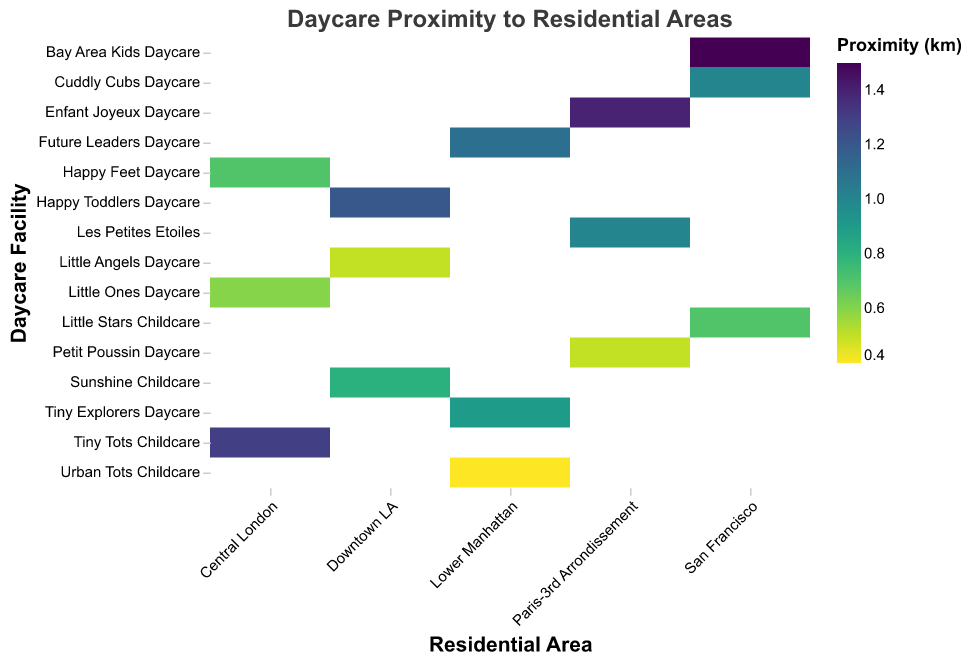what is the title of the heatmap? The heatmap's title is positioned at the top of the figure and describes the main subject of the data visualization. From the provided code, the title is given as "Daycare Proximity to Residential Areas".
Answer: Daycare Proximity to Residential Areas Which daycare facility is closest to a residential area in Lower Manhattan? To find the closest daycare facility, look for the daycare with the lowest proximity value in Lower Manhattan. From the data, "Urban Tots Childcare" has the smallest proximity value of 0.4 km in Lower Manhattan.
Answer: Urban Tots Childcare What is the smallest proximity value in Downtown LA? In Downtown LA, the proximity values are 0.5 (Little Angels Daycare), 1.2 (Happy Toddlers Daycare), and 0.8 (Sunshine Childcare). The smallest value is 0.5 km for Little Angels Daycare.
Answer: 0.5 km Which city has the daycare with the greatest average proximity to residential areas? Calculate the averages for each city: 
- Downtown LA: (0.5 + 1.2 + 0.8) / 3 = 0.83 km 
- San Francisco: (1.0 + 0.7 + 1.5) / 3 = 1.07 km 
- Lower Manhattan: (0.9 + 0.4 + 1.1) / 3 = 0.8 km 
- Central London: (0.6 + 1.3 + 0.7) / 3 = 0.87 km 
- Paris-3rd Arrondissement: (0.5 + 1.0 + 1.4) / 3 = 0.97 km 
San Francisco has the highest average proximity value of 1.07 km.
Answer: San Francisco Which residential area has the most daycare facilities within 1 km? Count the number of daycare facilities for each residential area with proximity values less than or equal to 1 km:
- Downtown LA: 2 (Little Angels Daycare, Sunshine Childcare)
- San Francisco: 2 (Cuddly Cubs Daycare, Little Stars Childcare)
- Lower Manhattan: 2 (Tiny Explorers Daycare, Urban Tots Childcare)
- Central London: 2 (Little Ones Daycare, Happy Feet Daycare)
- Paris-3rd Arrondissement: 2 (Petit Poussin Daycare, Les Petites Etoiles)
All these areas have 2 daycare facilities within 1 km.
Answer: Downtown LA, San Francisco, Lower Manhattan, Central London, Paris-3rd Arrondissement Which daycare facility is furthest from any residential area in Central London? To find the furthest daycare facility in Central London, look for the highest proximity value. The proximity values are 0.6 (Little Ones Daycare), 1.3 (Tiny Tots Childcare), and 0.7 (Happy Feet Daycare). Tiny Tots Childcare is the furthest with a proximity value of 1.3 km.
Answer: Tiny Tots Childcare 